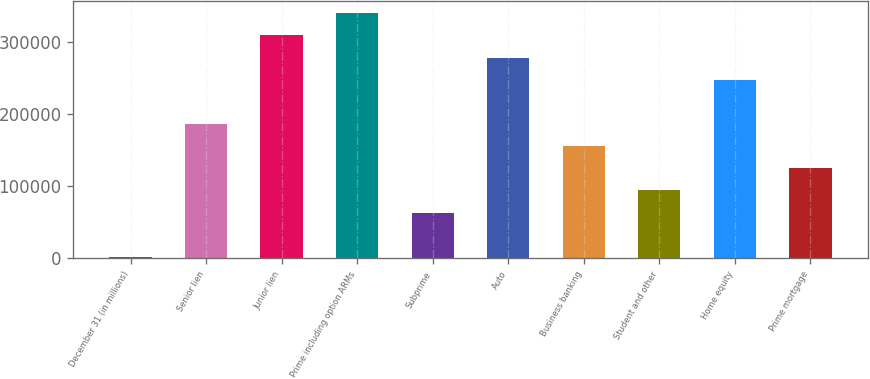Convert chart to OTSL. <chart><loc_0><loc_0><loc_500><loc_500><bar_chart><fcel>December 31 (in millions)<fcel>Senior lien<fcel>Junior lien<fcel>Prime including option ARMs<fcel>Subprime<fcel>Auto<fcel>Business banking<fcel>Student and other<fcel>Home equity<fcel>Prime mortgage<nl><fcel>2011<fcel>185861<fcel>308427<fcel>339069<fcel>63294.2<fcel>277785<fcel>155219<fcel>93935.8<fcel>247144<fcel>124577<nl></chart> 